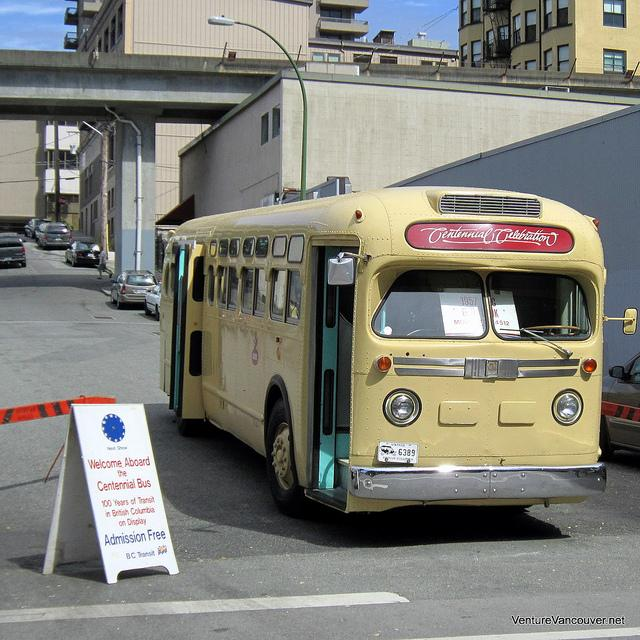This bus is part of what?

Choices:
A) reduced rides
B) sale
C) commute
D) exhibition exhibition 